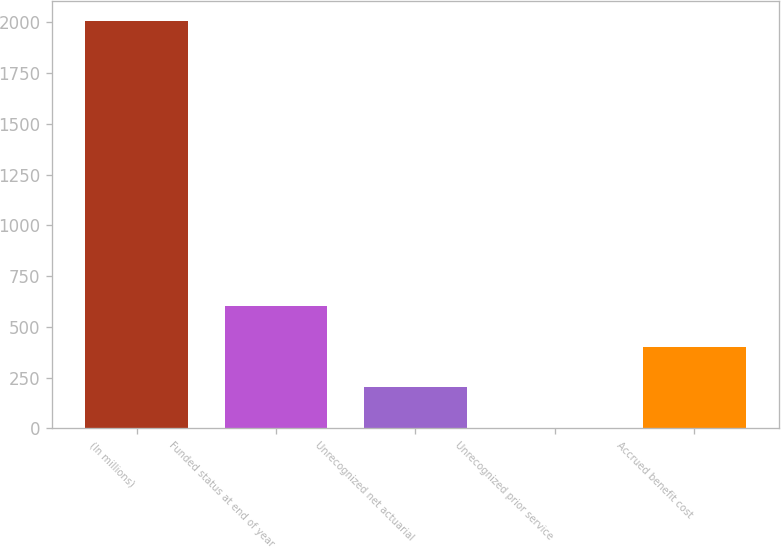<chart> <loc_0><loc_0><loc_500><loc_500><bar_chart><fcel>(In millions)<fcel>Funded status at end of year<fcel>Unrecognized net actuarial<fcel>Unrecognized prior service<fcel>Accrued benefit cost<nl><fcel>2005<fcel>603.18<fcel>202.66<fcel>2.4<fcel>402.92<nl></chart> 